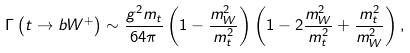Convert formula to latex. <formula><loc_0><loc_0><loc_500><loc_500>\Gamma \left ( t \rightarrow b W ^ { + } \right ) & \sim \frac { g ^ { 2 } m _ { t } } { 6 4 \pi } \left ( 1 - \frac { m _ { W } ^ { 2 } } { m _ { t } ^ { 2 } } \right ) \left ( 1 - 2 \frac { m _ { W } ^ { 2 } } { m _ { t } ^ { 2 } } + \frac { m _ { t } ^ { 2 } } { m _ { W } ^ { 2 } } \right ) ,</formula> 